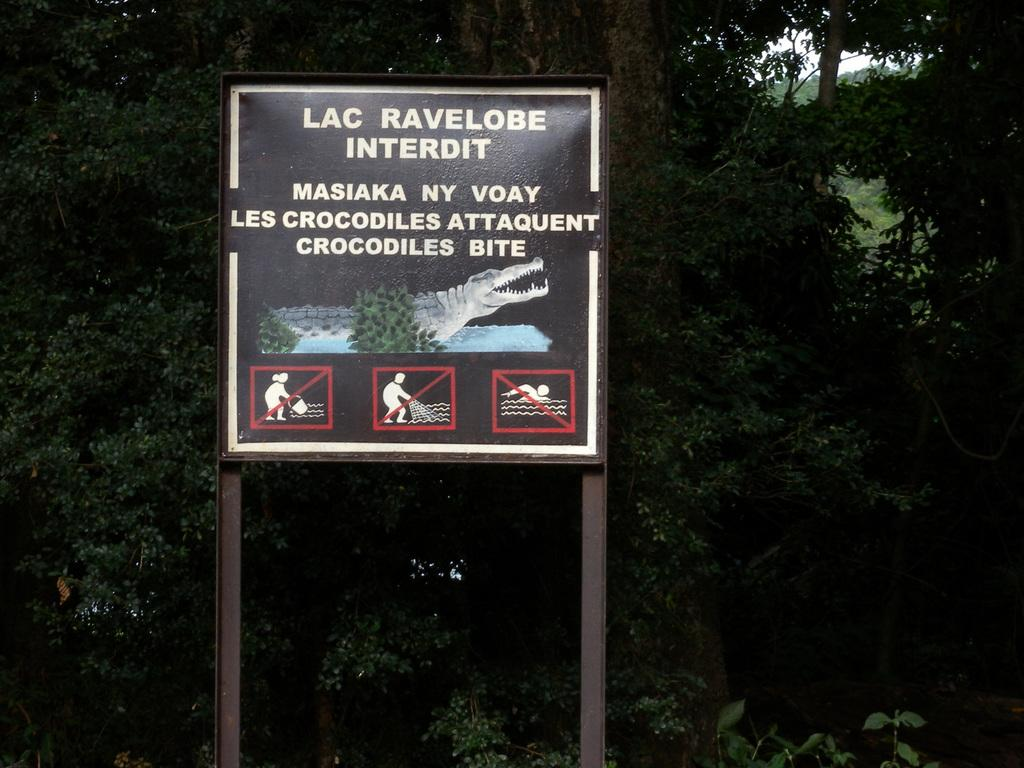What is hanging in the image? There is a banner in the image. What type of natural elements can be seen in the image? There are trees in the image. Can you describe the lighting in the image? The image appears to be slightly dark. Who is the creator of the jeans seen in the image? There are no jeans present in the image, so it is not possible to determine the creator. 